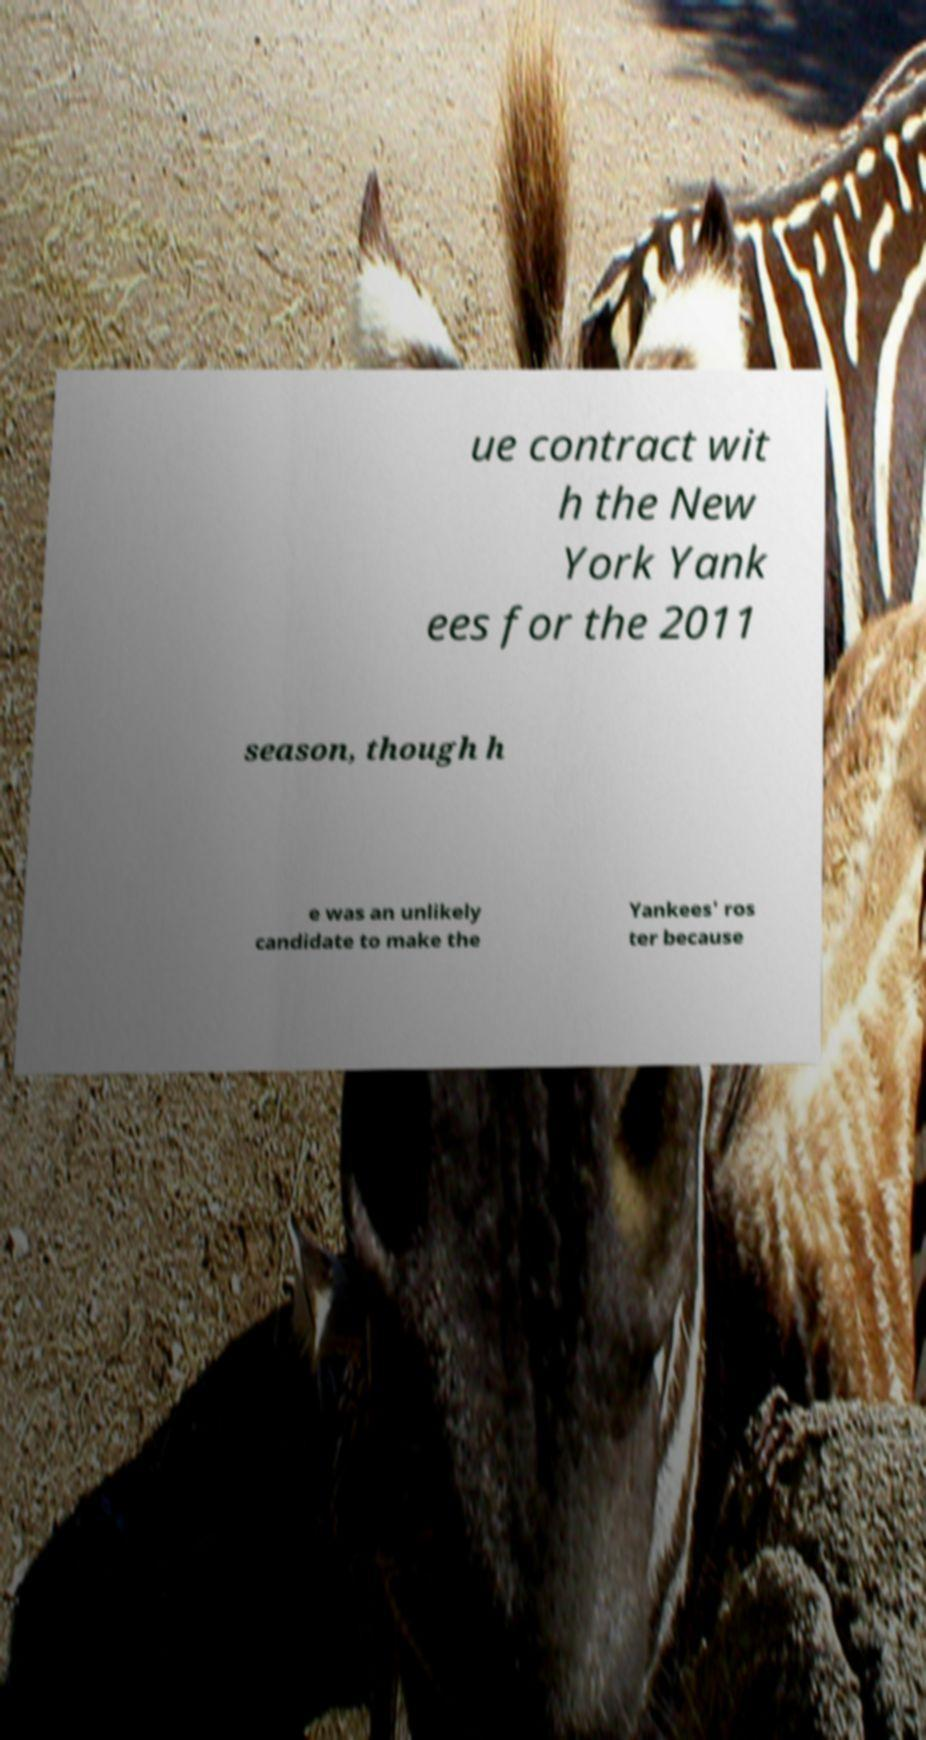I need the written content from this picture converted into text. Can you do that? ue contract wit h the New York Yank ees for the 2011 season, though h e was an unlikely candidate to make the Yankees' ros ter because 